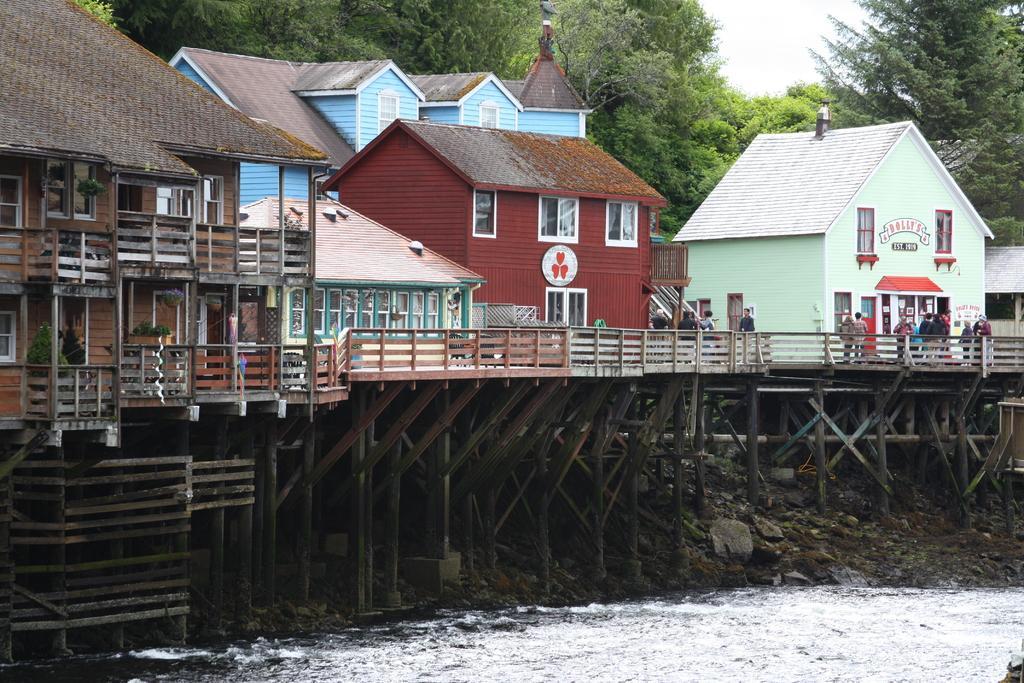Could you give a brief overview of what you see in this image? In this picture we can see water at the bottom, in the background there are some houses and trees, we can see some people on the right side, there is some grass and stones at the bottom, we can see the sky at the top of the picture, we can also see some plants on the left side. 